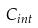<formula> <loc_0><loc_0><loc_500><loc_500>C _ { i n t }</formula> 